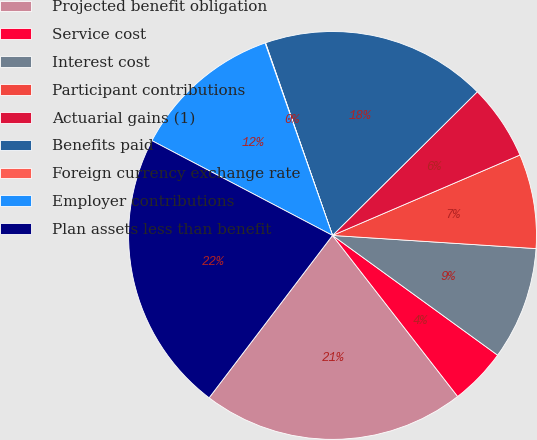Convert chart. <chart><loc_0><loc_0><loc_500><loc_500><pie_chart><fcel>Projected benefit obligation<fcel>Service cost<fcel>Interest cost<fcel>Participant contributions<fcel>Actuarial gains (1)<fcel>Benefits paid<fcel>Foreign currency exchange rate<fcel>Employer contributions<fcel>Plan assets less than benefit<nl><fcel>20.86%<fcel>4.5%<fcel>8.96%<fcel>7.48%<fcel>5.99%<fcel>17.89%<fcel>0.04%<fcel>11.94%<fcel>22.35%<nl></chart> 